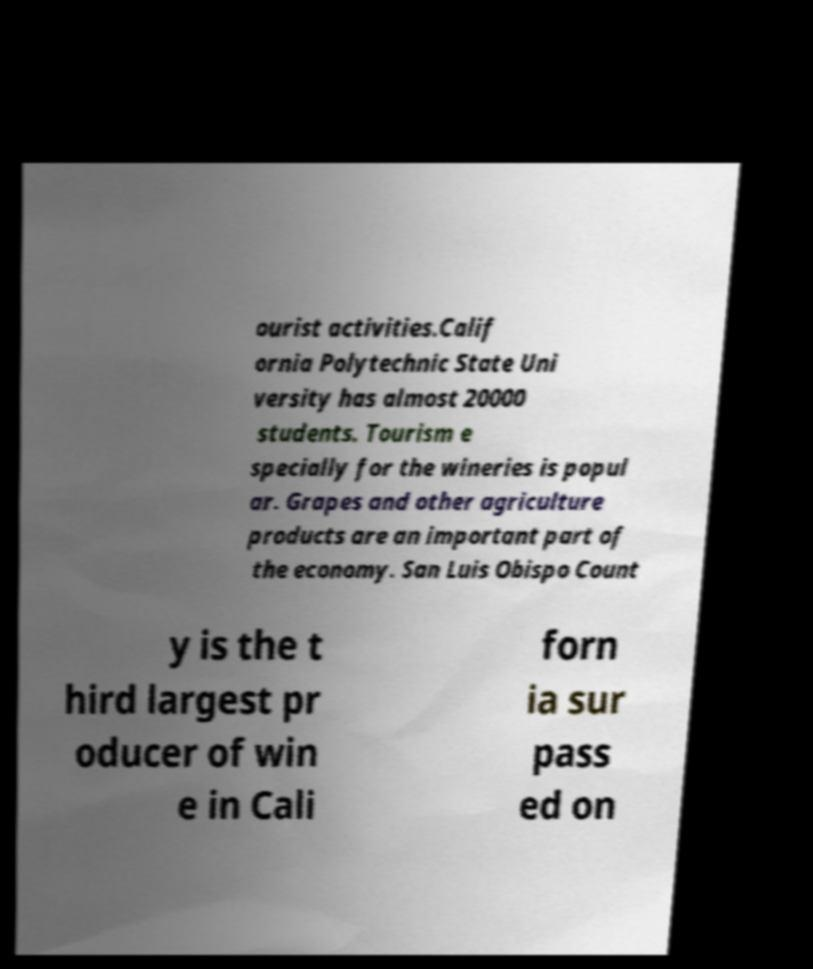Could you extract and type out the text from this image? ourist activities.Calif ornia Polytechnic State Uni versity has almost 20000 students. Tourism e specially for the wineries is popul ar. Grapes and other agriculture products are an important part of the economy. San Luis Obispo Count y is the t hird largest pr oducer of win e in Cali forn ia sur pass ed on 